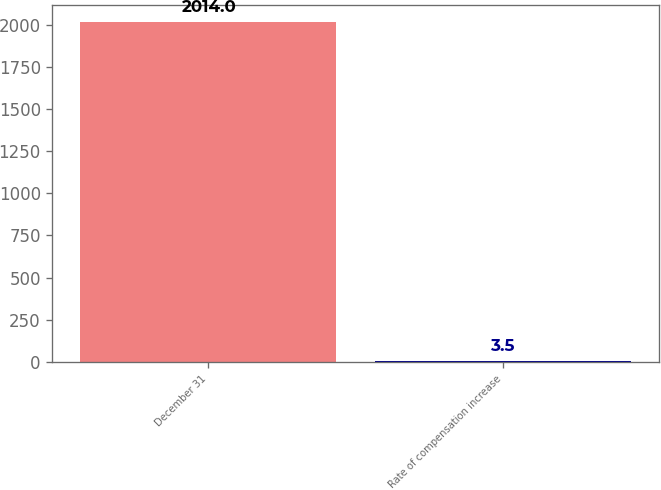<chart> <loc_0><loc_0><loc_500><loc_500><bar_chart><fcel>December 31<fcel>Rate of compensation increase<nl><fcel>2014<fcel>3.5<nl></chart> 